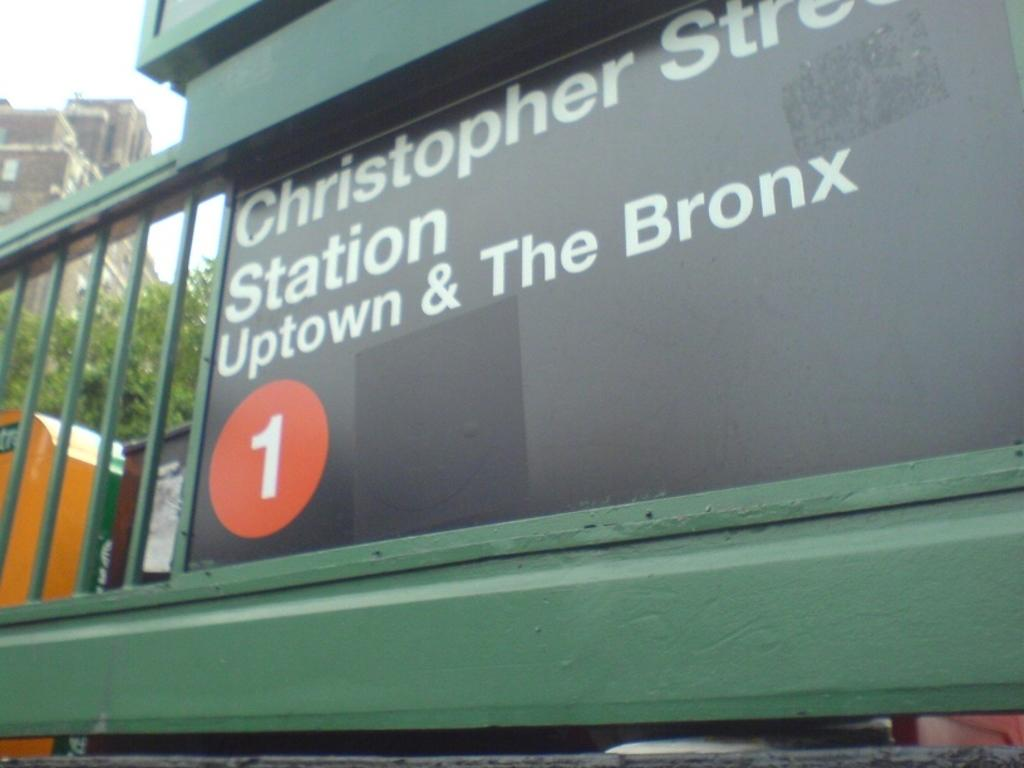What is on the board that is visible in the image? There is a board with text in the image. What can be seen in the distance behind the board? There are buildings and trees in the background of the image. Are there any other objects visible in the background? Yes, there are other objects visible in the background of the image. How does the decision affect the finger in the image? There is no decision or finger present in the image. 